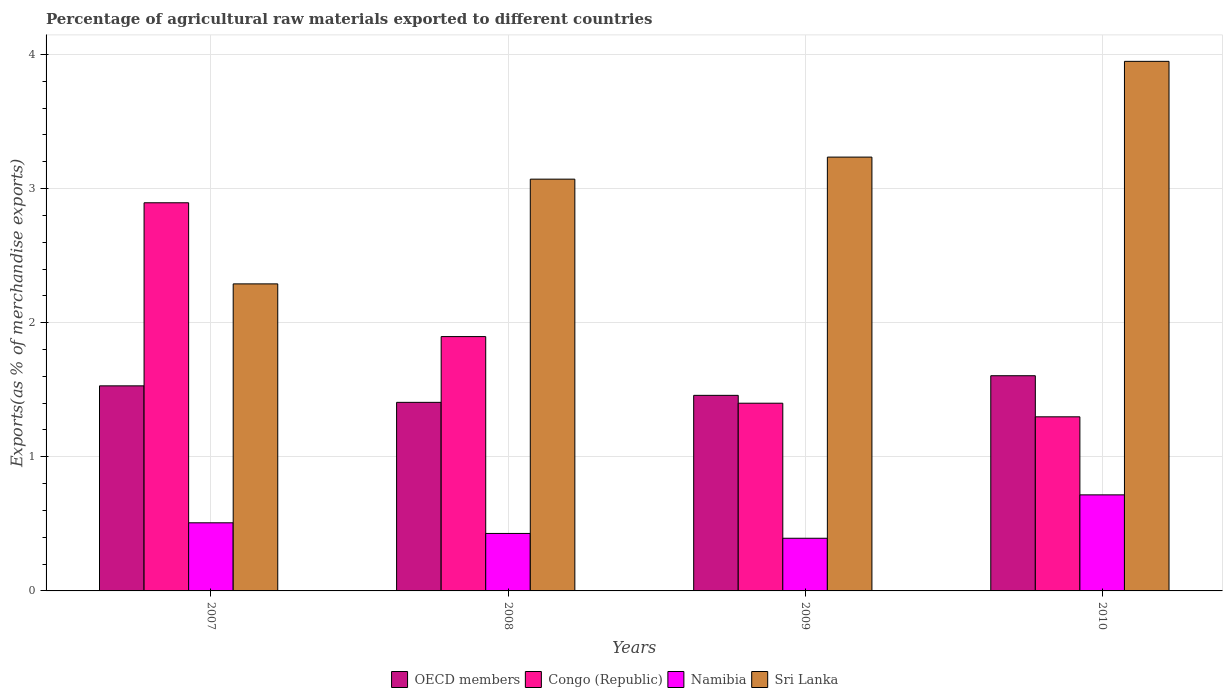How many groups of bars are there?
Give a very brief answer. 4. How many bars are there on the 4th tick from the right?
Make the answer very short. 4. What is the label of the 2nd group of bars from the left?
Offer a very short reply. 2008. What is the percentage of exports to different countries in Namibia in 2008?
Offer a terse response. 0.43. Across all years, what is the maximum percentage of exports to different countries in OECD members?
Your response must be concise. 1.6. Across all years, what is the minimum percentage of exports to different countries in Congo (Republic)?
Offer a very short reply. 1.3. What is the total percentage of exports to different countries in Congo (Republic) in the graph?
Make the answer very short. 7.49. What is the difference between the percentage of exports to different countries in Congo (Republic) in 2008 and that in 2009?
Keep it short and to the point. 0.5. What is the difference between the percentage of exports to different countries in OECD members in 2010 and the percentage of exports to different countries in Sri Lanka in 2009?
Your response must be concise. -1.63. What is the average percentage of exports to different countries in Congo (Republic) per year?
Give a very brief answer. 1.87. In the year 2007, what is the difference between the percentage of exports to different countries in Sri Lanka and percentage of exports to different countries in Congo (Republic)?
Your answer should be very brief. -0.6. In how many years, is the percentage of exports to different countries in Congo (Republic) greater than 3.2 %?
Ensure brevity in your answer.  0. What is the ratio of the percentage of exports to different countries in OECD members in 2007 to that in 2010?
Keep it short and to the point. 0.95. What is the difference between the highest and the second highest percentage of exports to different countries in Congo (Republic)?
Give a very brief answer. 1. What is the difference between the highest and the lowest percentage of exports to different countries in OECD members?
Give a very brief answer. 0.2. Is the sum of the percentage of exports to different countries in Sri Lanka in 2007 and 2008 greater than the maximum percentage of exports to different countries in OECD members across all years?
Provide a succinct answer. Yes. Is it the case that in every year, the sum of the percentage of exports to different countries in Sri Lanka and percentage of exports to different countries in Congo (Republic) is greater than the sum of percentage of exports to different countries in Namibia and percentage of exports to different countries in OECD members?
Offer a very short reply. Yes. What does the 2nd bar from the left in 2007 represents?
Keep it short and to the point. Congo (Republic). Is it the case that in every year, the sum of the percentage of exports to different countries in Congo (Republic) and percentage of exports to different countries in Sri Lanka is greater than the percentage of exports to different countries in OECD members?
Your answer should be compact. Yes. How many years are there in the graph?
Give a very brief answer. 4. Does the graph contain any zero values?
Ensure brevity in your answer.  No. Where does the legend appear in the graph?
Your answer should be very brief. Bottom center. How are the legend labels stacked?
Ensure brevity in your answer.  Horizontal. What is the title of the graph?
Provide a short and direct response. Percentage of agricultural raw materials exported to different countries. Does "Thailand" appear as one of the legend labels in the graph?
Make the answer very short. No. What is the label or title of the X-axis?
Offer a terse response. Years. What is the label or title of the Y-axis?
Your response must be concise. Exports(as % of merchandise exports). What is the Exports(as % of merchandise exports) in OECD members in 2007?
Ensure brevity in your answer.  1.53. What is the Exports(as % of merchandise exports) of Congo (Republic) in 2007?
Keep it short and to the point. 2.89. What is the Exports(as % of merchandise exports) of Namibia in 2007?
Give a very brief answer. 0.51. What is the Exports(as % of merchandise exports) in Sri Lanka in 2007?
Provide a short and direct response. 2.29. What is the Exports(as % of merchandise exports) in OECD members in 2008?
Provide a short and direct response. 1.41. What is the Exports(as % of merchandise exports) in Congo (Republic) in 2008?
Make the answer very short. 1.9. What is the Exports(as % of merchandise exports) of Namibia in 2008?
Provide a short and direct response. 0.43. What is the Exports(as % of merchandise exports) of Sri Lanka in 2008?
Provide a succinct answer. 3.07. What is the Exports(as % of merchandise exports) of OECD members in 2009?
Provide a short and direct response. 1.46. What is the Exports(as % of merchandise exports) of Congo (Republic) in 2009?
Keep it short and to the point. 1.4. What is the Exports(as % of merchandise exports) in Namibia in 2009?
Your response must be concise. 0.39. What is the Exports(as % of merchandise exports) in Sri Lanka in 2009?
Your answer should be compact. 3.23. What is the Exports(as % of merchandise exports) in OECD members in 2010?
Your response must be concise. 1.6. What is the Exports(as % of merchandise exports) in Congo (Republic) in 2010?
Provide a short and direct response. 1.3. What is the Exports(as % of merchandise exports) in Namibia in 2010?
Keep it short and to the point. 0.72. What is the Exports(as % of merchandise exports) of Sri Lanka in 2010?
Offer a terse response. 3.95. Across all years, what is the maximum Exports(as % of merchandise exports) of OECD members?
Ensure brevity in your answer.  1.6. Across all years, what is the maximum Exports(as % of merchandise exports) in Congo (Republic)?
Your response must be concise. 2.89. Across all years, what is the maximum Exports(as % of merchandise exports) of Namibia?
Your answer should be very brief. 0.72. Across all years, what is the maximum Exports(as % of merchandise exports) of Sri Lanka?
Your answer should be compact. 3.95. Across all years, what is the minimum Exports(as % of merchandise exports) of OECD members?
Offer a very short reply. 1.41. Across all years, what is the minimum Exports(as % of merchandise exports) in Congo (Republic)?
Give a very brief answer. 1.3. Across all years, what is the minimum Exports(as % of merchandise exports) of Namibia?
Ensure brevity in your answer.  0.39. Across all years, what is the minimum Exports(as % of merchandise exports) in Sri Lanka?
Your answer should be very brief. 2.29. What is the total Exports(as % of merchandise exports) of OECD members in the graph?
Keep it short and to the point. 6. What is the total Exports(as % of merchandise exports) of Congo (Republic) in the graph?
Your response must be concise. 7.49. What is the total Exports(as % of merchandise exports) in Namibia in the graph?
Offer a terse response. 2.05. What is the total Exports(as % of merchandise exports) of Sri Lanka in the graph?
Offer a terse response. 12.54. What is the difference between the Exports(as % of merchandise exports) in OECD members in 2007 and that in 2008?
Ensure brevity in your answer.  0.12. What is the difference between the Exports(as % of merchandise exports) of Congo (Republic) in 2007 and that in 2008?
Give a very brief answer. 1. What is the difference between the Exports(as % of merchandise exports) in Namibia in 2007 and that in 2008?
Your answer should be very brief. 0.08. What is the difference between the Exports(as % of merchandise exports) in Sri Lanka in 2007 and that in 2008?
Keep it short and to the point. -0.78. What is the difference between the Exports(as % of merchandise exports) of OECD members in 2007 and that in 2009?
Offer a terse response. 0.07. What is the difference between the Exports(as % of merchandise exports) of Congo (Republic) in 2007 and that in 2009?
Offer a very short reply. 1.49. What is the difference between the Exports(as % of merchandise exports) in Namibia in 2007 and that in 2009?
Give a very brief answer. 0.12. What is the difference between the Exports(as % of merchandise exports) of Sri Lanka in 2007 and that in 2009?
Offer a very short reply. -0.95. What is the difference between the Exports(as % of merchandise exports) of OECD members in 2007 and that in 2010?
Make the answer very short. -0.08. What is the difference between the Exports(as % of merchandise exports) of Congo (Republic) in 2007 and that in 2010?
Your response must be concise. 1.6. What is the difference between the Exports(as % of merchandise exports) in Namibia in 2007 and that in 2010?
Offer a very short reply. -0.21. What is the difference between the Exports(as % of merchandise exports) of Sri Lanka in 2007 and that in 2010?
Offer a terse response. -1.66. What is the difference between the Exports(as % of merchandise exports) in OECD members in 2008 and that in 2009?
Provide a short and direct response. -0.05. What is the difference between the Exports(as % of merchandise exports) of Congo (Republic) in 2008 and that in 2009?
Ensure brevity in your answer.  0.5. What is the difference between the Exports(as % of merchandise exports) of Namibia in 2008 and that in 2009?
Offer a very short reply. 0.04. What is the difference between the Exports(as % of merchandise exports) of Sri Lanka in 2008 and that in 2009?
Your response must be concise. -0.16. What is the difference between the Exports(as % of merchandise exports) in OECD members in 2008 and that in 2010?
Ensure brevity in your answer.  -0.2. What is the difference between the Exports(as % of merchandise exports) in Congo (Republic) in 2008 and that in 2010?
Your answer should be compact. 0.6. What is the difference between the Exports(as % of merchandise exports) in Namibia in 2008 and that in 2010?
Keep it short and to the point. -0.29. What is the difference between the Exports(as % of merchandise exports) in Sri Lanka in 2008 and that in 2010?
Make the answer very short. -0.88. What is the difference between the Exports(as % of merchandise exports) in OECD members in 2009 and that in 2010?
Give a very brief answer. -0.15. What is the difference between the Exports(as % of merchandise exports) in Congo (Republic) in 2009 and that in 2010?
Keep it short and to the point. 0.1. What is the difference between the Exports(as % of merchandise exports) in Namibia in 2009 and that in 2010?
Give a very brief answer. -0.32. What is the difference between the Exports(as % of merchandise exports) in Sri Lanka in 2009 and that in 2010?
Ensure brevity in your answer.  -0.71. What is the difference between the Exports(as % of merchandise exports) in OECD members in 2007 and the Exports(as % of merchandise exports) in Congo (Republic) in 2008?
Your response must be concise. -0.37. What is the difference between the Exports(as % of merchandise exports) of OECD members in 2007 and the Exports(as % of merchandise exports) of Namibia in 2008?
Provide a short and direct response. 1.1. What is the difference between the Exports(as % of merchandise exports) of OECD members in 2007 and the Exports(as % of merchandise exports) of Sri Lanka in 2008?
Your response must be concise. -1.54. What is the difference between the Exports(as % of merchandise exports) in Congo (Republic) in 2007 and the Exports(as % of merchandise exports) in Namibia in 2008?
Provide a short and direct response. 2.47. What is the difference between the Exports(as % of merchandise exports) of Congo (Republic) in 2007 and the Exports(as % of merchandise exports) of Sri Lanka in 2008?
Your answer should be very brief. -0.18. What is the difference between the Exports(as % of merchandise exports) in Namibia in 2007 and the Exports(as % of merchandise exports) in Sri Lanka in 2008?
Provide a succinct answer. -2.56. What is the difference between the Exports(as % of merchandise exports) of OECD members in 2007 and the Exports(as % of merchandise exports) of Congo (Republic) in 2009?
Provide a short and direct response. 0.13. What is the difference between the Exports(as % of merchandise exports) in OECD members in 2007 and the Exports(as % of merchandise exports) in Namibia in 2009?
Provide a succinct answer. 1.14. What is the difference between the Exports(as % of merchandise exports) in OECD members in 2007 and the Exports(as % of merchandise exports) in Sri Lanka in 2009?
Offer a very short reply. -1.71. What is the difference between the Exports(as % of merchandise exports) in Congo (Republic) in 2007 and the Exports(as % of merchandise exports) in Namibia in 2009?
Provide a short and direct response. 2.5. What is the difference between the Exports(as % of merchandise exports) in Congo (Republic) in 2007 and the Exports(as % of merchandise exports) in Sri Lanka in 2009?
Your answer should be compact. -0.34. What is the difference between the Exports(as % of merchandise exports) in Namibia in 2007 and the Exports(as % of merchandise exports) in Sri Lanka in 2009?
Offer a terse response. -2.73. What is the difference between the Exports(as % of merchandise exports) of OECD members in 2007 and the Exports(as % of merchandise exports) of Congo (Republic) in 2010?
Keep it short and to the point. 0.23. What is the difference between the Exports(as % of merchandise exports) of OECD members in 2007 and the Exports(as % of merchandise exports) of Namibia in 2010?
Your answer should be compact. 0.81. What is the difference between the Exports(as % of merchandise exports) of OECD members in 2007 and the Exports(as % of merchandise exports) of Sri Lanka in 2010?
Your answer should be very brief. -2.42. What is the difference between the Exports(as % of merchandise exports) of Congo (Republic) in 2007 and the Exports(as % of merchandise exports) of Namibia in 2010?
Make the answer very short. 2.18. What is the difference between the Exports(as % of merchandise exports) of Congo (Republic) in 2007 and the Exports(as % of merchandise exports) of Sri Lanka in 2010?
Your response must be concise. -1.05. What is the difference between the Exports(as % of merchandise exports) of Namibia in 2007 and the Exports(as % of merchandise exports) of Sri Lanka in 2010?
Keep it short and to the point. -3.44. What is the difference between the Exports(as % of merchandise exports) in OECD members in 2008 and the Exports(as % of merchandise exports) in Congo (Republic) in 2009?
Offer a terse response. 0.01. What is the difference between the Exports(as % of merchandise exports) of OECD members in 2008 and the Exports(as % of merchandise exports) of Namibia in 2009?
Ensure brevity in your answer.  1.01. What is the difference between the Exports(as % of merchandise exports) of OECD members in 2008 and the Exports(as % of merchandise exports) of Sri Lanka in 2009?
Provide a succinct answer. -1.83. What is the difference between the Exports(as % of merchandise exports) in Congo (Republic) in 2008 and the Exports(as % of merchandise exports) in Namibia in 2009?
Provide a short and direct response. 1.5. What is the difference between the Exports(as % of merchandise exports) in Congo (Republic) in 2008 and the Exports(as % of merchandise exports) in Sri Lanka in 2009?
Your response must be concise. -1.34. What is the difference between the Exports(as % of merchandise exports) in Namibia in 2008 and the Exports(as % of merchandise exports) in Sri Lanka in 2009?
Your answer should be very brief. -2.81. What is the difference between the Exports(as % of merchandise exports) in OECD members in 2008 and the Exports(as % of merchandise exports) in Congo (Republic) in 2010?
Your response must be concise. 0.11. What is the difference between the Exports(as % of merchandise exports) of OECD members in 2008 and the Exports(as % of merchandise exports) of Namibia in 2010?
Offer a terse response. 0.69. What is the difference between the Exports(as % of merchandise exports) in OECD members in 2008 and the Exports(as % of merchandise exports) in Sri Lanka in 2010?
Ensure brevity in your answer.  -2.54. What is the difference between the Exports(as % of merchandise exports) in Congo (Republic) in 2008 and the Exports(as % of merchandise exports) in Namibia in 2010?
Your answer should be compact. 1.18. What is the difference between the Exports(as % of merchandise exports) in Congo (Republic) in 2008 and the Exports(as % of merchandise exports) in Sri Lanka in 2010?
Your answer should be very brief. -2.05. What is the difference between the Exports(as % of merchandise exports) of Namibia in 2008 and the Exports(as % of merchandise exports) of Sri Lanka in 2010?
Provide a short and direct response. -3.52. What is the difference between the Exports(as % of merchandise exports) in OECD members in 2009 and the Exports(as % of merchandise exports) in Congo (Republic) in 2010?
Offer a very short reply. 0.16. What is the difference between the Exports(as % of merchandise exports) in OECD members in 2009 and the Exports(as % of merchandise exports) in Namibia in 2010?
Make the answer very short. 0.74. What is the difference between the Exports(as % of merchandise exports) in OECD members in 2009 and the Exports(as % of merchandise exports) in Sri Lanka in 2010?
Provide a short and direct response. -2.49. What is the difference between the Exports(as % of merchandise exports) in Congo (Republic) in 2009 and the Exports(as % of merchandise exports) in Namibia in 2010?
Offer a very short reply. 0.68. What is the difference between the Exports(as % of merchandise exports) in Congo (Republic) in 2009 and the Exports(as % of merchandise exports) in Sri Lanka in 2010?
Provide a short and direct response. -2.55. What is the difference between the Exports(as % of merchandise exports) in Namibia in 2009 and the Exports(as % of merchandise exports) in Sri Lanka in 2010?
Ensure brevity in your answer.  -3.56. What is the average Exports(as % of merchandise exports) in OECD members per year?
Keep it short and to the point. 1.5. What is the average Exports(as % of merchandise exports) of Congo (Republic) per year?
Make the answer very short. 1.87. What is the average Exports(as % of merchandise exports) of Namibia per year?
Provide a short and direct response. 0.51. What is the average Exports(as % of merchandise exports) of Sri Lanka per year?
Ensure brevity in your answer.  3.14. In the year 2007, what is the difference between the Exports(as % of merchandise exports) of OECD members and Exports(as % of merchandise exports) of Congo (Republic)?
Your answer should be compact. -1.36. In the year 2007, what is the difference between the Exports(as % of merchandise exports) in OECD members and Exports(as % of merchandise exports) in Namibia?
Keep it short and to the point. 1.02. In the year 2007, what is the difference between the Exports(as % of merchandise exports) of OECD members and Exports(as % of merchandise exports) of Sri Lanka?
Keep it short and to the point. -0.76. In the year 2007, what is the difference between the Exports(as % of merchandise exports) of Congo (Republic) and Exports(as % of merchandise exports) of Namibia?
Provide a succinct answer. 2.39. In the year 2007, what is the difference between the Exports(as % of merchandise exports) of Congo (Republic) and Exports(as % of merchandise exports) of Sri Lanka?
Make the answer very short. 0.6. In the year 2007, what is the difference between the Exports(as % of merchandise exports) in Namibia and Exports(as % of merchandise exports) in Sri Lanka?
Your answer should be compact. -1.78. In the year 2008, what is the difference between the Exports(as % of merchandise exports) of OECD members and Exports(as % of merchandise exports) of Congo (Republic)?
Your answer should be compact. -0.49. In the year 2008, what is the difference between the Exports(as % of merchandise exports) in OECD members and Exports(as % of merchandise exports) in Namibia?
Your answer should be compact. 0.98. In the year 2008, what is the difference between the Exports(as % of merchandise exports) of OECD members and Exports(as % of merchandise exports) of Sri Lanka?
Your answer should be very brief. -1.66. In the year 2008, what is the difference between the Exports(as % of merchandise exports) in Congo (Republic) and Exports(as % of merchandise exports) in Namibia?
Offer a very short reply. 1.47. In the year 2008, what is the difference between the Exports(as % of merchandise exports) in Congo (Republic) and Exports(as % of merchandise exports) in Sri Lanka?
Provide a succinct answer. -1.17. In the year 2008, what is the difference between the Exports(as % of merchandise exports) in Namibia and Exports(as % of merchandise exports) in Sri Lanka?
Provide a short and direct response. -2.64. In the year 2009, what is the difference between the Exports(as % of merchandise exports) in OECD members and Exports(as % of merchandise exports) in Congo (Republic)?
Your response must be concise. 0.06. In the year 2009, what is the difference between the Exports(as % of merchandise exports) of OECD members and Exports(as % of merchandise exports) of Namibia?
Keep it short and to the point. 1.07. In the year 2009, what is the difference between the Exports(as % of merchandise exports) of OECD members and Exports(as % of merchandise exports) of Sri Lanka?
Your answer should be compact. -1.78. In the year 2009, what is the difference between the Exports(as % of merchandise exports) of Congo (Republic) and Exports(as % of merchandise exports) of Namibia?
Ensure brevity in your answer.  1.01. In the year 2009, what is the difference between the Exports(as % of merchandise exports) of Congo (Republic) and Exports(as % of merchandise exports) of Sri Lanka?
Make the answer very short. -1.83. In the year 2009, what is the difference between the Exports(as % of merchandise exports) in Namibia and Exports(as % of merchandise exports) in Sri Lanka?
Your answer should be very brief. -2.84. In the year 2010, what is the difference between the Exports(as % of merchandise exports) in OECD members and Exports(as % of merchandise exports) in Congo (Republic)?
Provide a short and direct response. 0.31. In the year 2010, what is the difference between the Exports(as % of merchandise exports) in OECD members and Exports(as % of merchandise exports) in Namibia?
Keep it short and to the point. 0.89. In the year 2010, what is the difference between the Exports(as % of merchandise exports) in OECD members and Exports(as % of merchandise exports) in Sri Lanka?
Your answer should be compact. -2.34. In the year 2010, what is the difference between the Exports(as % of merchandise exports) of Congo (Republic) and Exports(as % of merchandise exports) of Namibia?
Keep it short and to the point. 0.58. In the year 2010, what is the difference between the Exports(as % of merchandise exports) of Congo (Republic) and Exports(as % of merchandise exports) of Sri Lanka?
Offer a very short reply. -2.65. In the year 2010, what is the difference between the Exports(as % of merchandise exports) of Namibia and Exports(as % of merchandise exports) of Sri Lanka?
Provide a succinct answer. -3.23. What is the ratio of the Exports(as % of merchandise exports) in OECD members in 2007 to that in 2008?
Offer a very short reply. 1.09. What is the ratio of the Exports(as % of merchandise exports) of Congo (Republic) in 2007 to that in 2008?
Your response must be concise. 1.53. What is the ratio of the Exports(as % of merchandise exports) in Namibia in 2007 to that in 2008?
Your answer should be very brief. 1.19. What is the ratio of the Exports(as % of merchandise exports) of Sri Lanka in 2007 to that in 2008?
Ensure brevity in your answer.  0.75. What is the ratio of the Exports(as % of merchandise exports) of OECD members in 2007 to that in 2009?
Your response must be concise. 1.05. What is the ratio of the Exports(as % of merchandise exports) of Congo (Republic) in 2007 to that in 2009?
Provide a succinct answer. 2.07. What is the ratio of the Exports(as % of merchandise exports) in Namibia in 2007 to that in 2009?
Keep it short and to the point. 1.29. What is the ratio of the Exports(as % of merchandise exports) in Sri Lanka in 2007 to that in 2009?
Provide a succinct answer. 0.71. What is the ratio of the Exports(as % of merchandise exports) of OECD members in 2007 to that in 2010?
Provide a short and direct response. 0.95. What is the ratio of the Exports(as % of merchandise exports) of Congo (Republic) in 2007 to that in 2010?
Make the answer very short. 2.23. What is the ratio of the Exports(as % of merchandise exports) in Namibia in 2007 to that in 2010?
Offer a very short reply. 0.71. What is the ratio of the Exports(as % of merchandise exports) of Sri Lanka in 2007 to that in 2010?
Ensure brevity in your answer.  0.58. What is the ratio of the Exports(as % of merchandise exports) of OECD members in 2008 to that in 2009?
Ensure brevity in your answer.  0.96. What is the ratio of the Exports(as % of merchandise exports) in Congo (Republic) in 2008 to that in 2009?
Offer a terse response. 1.35. What is the ratio of the Exports(as % of merchandise exports) of Namibia in 2008 to that in 2009?
Give a very brief answer. 1.09. What is the ratio of the Exports(as % of merchandise exports) in Sri Lanka in 2008 to that in 2009?
Keep it short and to the point. 0.95. What is the ratio of the Exports(as % of merchandise exports) of OECD members in 2008 to that in 2010?
Offer a very short reply. 0.88. What is the ratio of the Exports(as % of merchandise exports) of Congo (Republic) in 2008 to that in 2010?
Offer a very short reply. 1.46. What is the ratio of the Exports(as % of merchandise exports) in Namibia in 2008 to that in 2010?
Provide a short and direct response. 0.6. What is the ratio of the Exports(as % of merchandise exports) in Sri Lanka in 2008 to that in 2010?
Your answer should be very brief. 0.78. What is the ratio of the Exports(as % of merchandise exports) in OECD members in 2009 to that in 2010?
Provide a succinct answer. 0.91. What is the ratio of the Exports(as % of merchandise exports) in Congo (Republic) in 2009 to that in 2010?
Your answer should be compact. 1.08. What is the ratio of the Exports(as % of merchandise exports) of Namibia in 2009 to that in 2010?
Make the answer very short. 0.55. What is the ratio of the Exports(as % of merchandise exports) of Sri Lanka in 2009 to that in 2010?
Keep it short and to the point. 0.82. What is the difference between the highest and the second highest Exports(as % of merchandise exports) in OECD members?
Your answer should be compact. 0.08. What is the difference between the highest and the second highest Exports(as % of merchandise exports) of Congo (Republic)?
Your response must be concise. 1. What is the difference between the highest and the second highest Exports(as % of merchandise exports) of Namibia?
Keep it short and to the point. 0.21. What is the difference between the highest and the second highest Exports(as % of merchandise exports) in Sri Lanka?
Your response must be concise. 0.71. What is the difference between the highest and the lowest Exports(as % of merchandise exports) of OECD members?
Your answer should be compact. 0.2. What is the difference between the highest and the lowest Exports(as % of merchandise exports) of Congo (Republic)?
Offer a terse response. 1.6. What is the difference between the highest and the lowest Exports(as % of merchandise exports) of Namibia?
Offer a very short reply. 0.32. What is the difference between the highest and the lowest Exports(as % of merchandise exports) of Sri Lanka?
Your answer should be very brief. 1.66. 